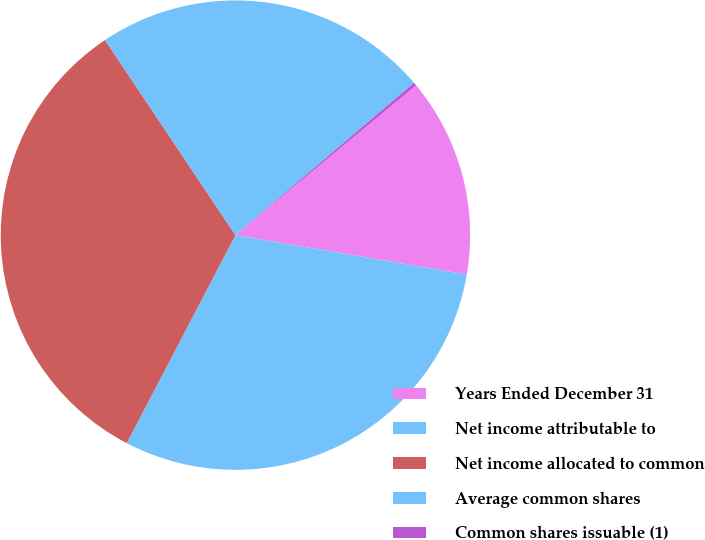Convert chart. <chart><loc_0><loc_0><loc_500><loc_500><pie_chart><fcel>Years Ended December 31<fcel>Net income attributable to<fcel>Net income allocated to common<fcel>Average common shares<fcel>Common shares issuable (1)<nl><fcel>13.7%<fcel>29.98%<fcel>32.95%<fcel>23.14%<fcel>0.22%<nl></chart> 